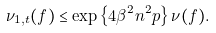Convert formula to latex. <formula><loc_0><loc_0><loc_500><loc_500>\nu _ { 1 , t } ( f ) \leq \exp \left \{ 4 \beta ^ { 2 } n ^ { 2 } p \right \} \nu ( f ) .</formula> 